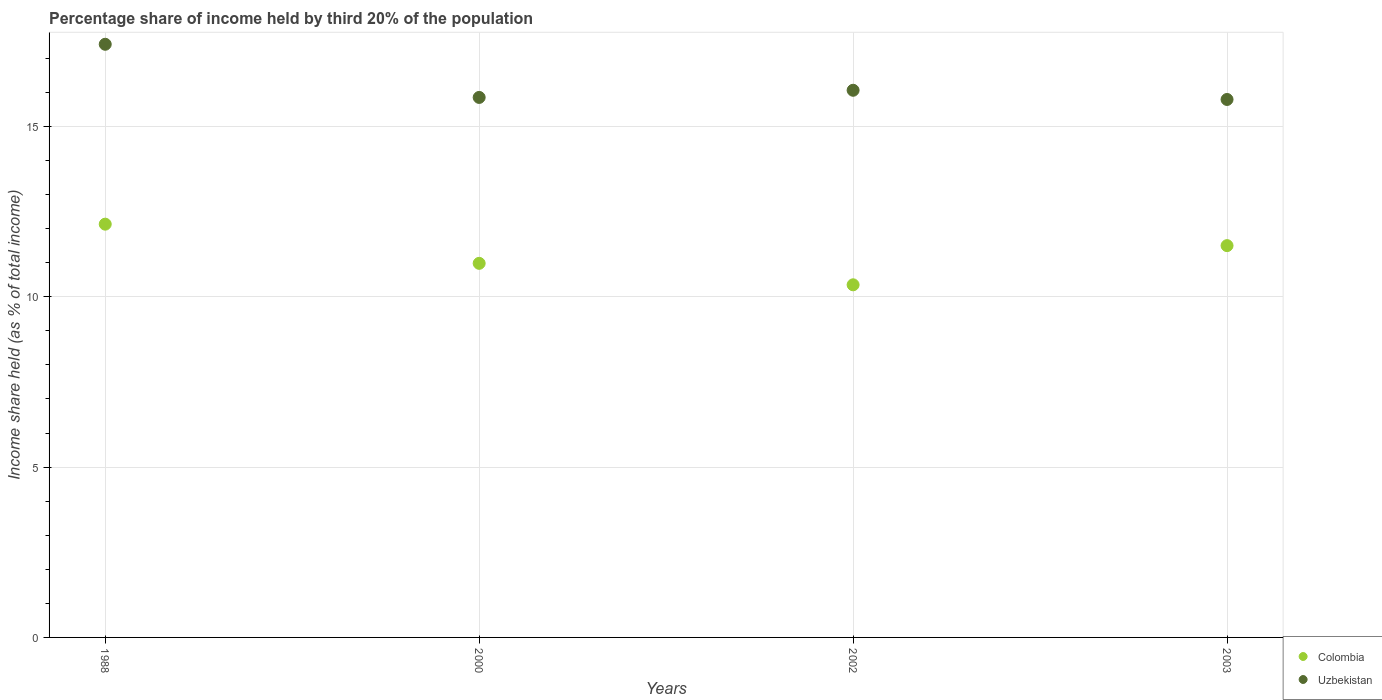How many different coloured dotlines are there?
Provide a short and direct response. 2. Is the number of dotlines equal to the number of legend labels?
Give a very brief answer. Yes. What is the share of income held by third 20% of the population in Colombia in 2000?
Provide a short and direct response. 10.98. Across all years, what is the maximum share of income held by third 20% of the population in Uzbekistan?
Provide a short and direct response. 17.41. Across all years, what is the minimum share of income held by third 20% of the population in Uzbekistan?
Give a very brief answer. 15.79. What is the total share of income held by third 20% of the population in Uzbekistan in the graph?
Provide a short and direct response. 65.11. What is the difference between the share of income held by third 20% of the population in Uzbekistan in 1988 and that in 2000?
Give a very brief answer. 1.56. What is the difference between the share of income held by third 20% of the population in Colombia in 1988 and the share of income held by third 20% of the population in Uzbekistan in 2003?
Provide a short and direct response. -3.66. What is the average share of income held by third 20% of the population in Uzbekistan per year?
Provide a succinct answer. 16.28. In the year 2002, what is the difference between the share of income held by third 20% of the population in Uzbekistan and share of income held by third 20% of the population in Colombia?
Ensure brevity in your answer.  5.71. In how many years, is the share of income held by third 20% of the population in Uzbekistan greater than 16 %?
Make the answer very short. 2. What is the ratio of the share of income held by third 20% of the population in Uzbekistan in 2000 to that in 2003?
Provide a succinct answer. 1. Is the share of income held by third 20% of the population in Uzbekistan in 2000 less than that in 2003?
Make the answer very short. No. Is the difference between the share of income held by third 20% of the population in Uzbekistan in 1988 and 2003 greater than the difference between the share of income held by third 20% of the population in Colombia in 1988 and 2003?
Ensure brevity in your answer.  Yes. What is the difference between the highest and the second highest share of income held by third 20% of the population in Uzbekistan?
Provide a succinct answer. 1.35. What is the difference between the highest and the lowest share of income held by third 20% of the population in Colombia?
Your answer should be very brief. 1.78. In how many years, is the share of income held by third 20% of the population in Uzbekistan greater than the average share of income held by third 20% of the population in Uzbekistan taken over all years?
Your answer should be very brief. 1. Is the sum of the share of income held by third 20% of the population in Colombia in 2000 and 2003 greater than the maximum share of income held by third 20% of the population in Uzbekistan across all years?
Your answer should be compact. Yes. Is the share of income held by third 20% of the population in Colombia strictly greater than the share of income held by third 20% of the population in Uzbekistan over the years?
Provide a short and direct response. No. Is the share of income held by third 20% of the population in Colombia strictly less than the share of income held by third 20% of the population in Uzbekistan over the years?
Keep it short and to the point. Yes. What is the difference between two consecutive major ticks on the Y-axis?
Your answer should be compact. 5. Does the graph contain any zero values?
Keep it short and to the point. No. Does the graph contain grids?
Your answer should be very brief. Yes. Where does the legend appear in the graph?
Provide a short and direct response. Bottom right. How many legend labels are there?
Keep it short and to the point. 2. How are the legend labels stacked?
Provide a short and direct response. Vertical. What is the title of the graph?
Provide a succinct answer. Percentage share of income held by third 20% of the population. What is the label or title of the X-axis?
Ensure brevity in your answer.  Years. What is the label or title of the Y-axis?
Keep it short and to the point. Income share held (as % of total income). What is the Income share held (as % of total income) in Colombia in 1988?
Provide a succinct answer. 12.13. What is the Income share held (as % of total income) in Uzbekistan in 1988?
Keep it short and to the point. 17.41. What is the Income share held (as % of total income) in Colombia in 2000?
Your response must be concise. 10.98. What is the Income share held (as % of total income) in Uzbekistan in 2000?
Ensure brevity in your answer.  15.85. What is the Income share held (as % of total income) in Colombia in 2002?
Your answer should be very brief. 10.35. What is the Income share held (as % of total income) in Uzbekistan in 2002?
Provide a short and direct response. 16.06. What is the Income share held (as % of total income) in Colombia in 2003?
Offer a very short reply. 11.5. What is the Income share held (as % of total income) of Uzbekistan in 2003?
Provide a short and direct response. 15.79. Across all years, what is the maximum Income share held (as % of total income) in Colombia?
Your answer should be compact. 12.13. Across all years, what is the maximum Income share held (as % of total income) of Uzbekistan?
Your answer should be compact. 17.41. Across all years, what is the minimum Income share held (as % of total income) in Colombia?
Your answer should be very brief. 10.35. Across all years, what is the minimum Income share held (as % of total income) in Uzbekistan?
Offer a terse response. 15.79. What is the total Income share held (as % of total income) of Colombia in the graph?
Give a very brief answer. 44.96. What is the total Income share held (as % of total income) of Uzbekistan in the graph?
Your response must be concise. 65.11. What is the difference between the Income share held (as % of total income) of Colombia in 1988 and that in 2000?
Offer a very short reply. 1.15. What is the difference between the Income share held (as % of total income) of Uzbekistan in 1988 and that in 2000?
Your answer should be very brief. 1.56. What is the difference between the Income share held (as % of total income) of Colombia in 1988 and that in 2002?
Provide a short and direct response. 1.78. What is the difference between the Income share held (as % of total income) in Uzbekistan in 1988 and that in 2002?
Your response must be concise. 1.35. What is the difference between the Income share held (as % of total income) in Colombia in 1988 and that in 2003?
Keep it short and to the point. 0.63. What is the difference between the Income share held (as % of total income) of Uzbekistan in 1988 and that in 2003?
Your answer should be compact. 1.62. What is the difference between the Income share held (as % of total income) in Colombia in 2000 and that in 2002?
Make the answer very short. 0.63. What is the difference between the Income share held (as % of total income) of Uzbekistan in 2000 and that in 2002?
Give a very brief answer. -0.21. What is the difference between the Income share held (as % of total income) of Colombia in 2000 and that in 2003?
Provide a succinct answer. -0.52. What is the difference between the Income share held (as % of total income) of Uzbekistan in 2000 and that in 2003?
Your response must be concise. 0.06. What is the difference between the Income share held (as % of total income) in Colombia in 2002 and that in 2003?
Keep it short and to the point. -1.15. What is the difference between the Income share held (as % of total income) in Uzbekistan in 2002 and that in 2003?
Your answer should be very brief. 0.27. What is the difference between the Income share held (as % of total income) of Colombia in 1988 and the Income share held (as % of total income) of Uzbekistan in 2000?
Your answer should be very brief. -3.72. What is the difference between the Income share held (as % of total income) in Colombia in 1988 and the Income share held (as % of total income) in Uzbekistan in 2002?
Offer a terse response. -3.93. What is the difference between the Income share held (as % of total income) of Colombia in 1988 and the Income share held (as % of total income) of Uzbekistan in 2003?
Offer a terse response. -3.66. What is the difference between the Income share held (as % of total income) in Colombia in 2000 and the Income share held (as % of total income) in Uzbekistan in 2002?
Provide a succinct answer. -5.08. What is the difference between the Income share held (as % of total income) of Colombia in 2000 and the Income share held (as % of total income) of Uzbekistan in 2003?
Make the answer very short. -4.81. What is the difference between the Income share held (as % of total income) of Colombia in 2002 and the Income share held (as % of total income) of Uzbekistan in 2003?
Provide a short and direct response. -5.44. What is the average Income share held (as % of total income) in Colombia per year?
Keep it short and to the point. 11.24. What is the average Income share held (as % of total income) in Uzbekistan per year?
Keep it short and to the point. 16.28. In the year 1988, what is the difference between the Income share held (as % of total income) of Colombia and Income share held (as % of total income) of Uzbekistan?
Give a very brief answer. -5.28. In the year 2000, what is the difference between the Income share held (as % of total income) of Colombia and Income share held (as % of total income) of Uzbekistan?
Your response must be concise. -4.87. In the year 2002, what is the difference between the Income share held (as % of total income) in Colombia and Income share held (as % of total income) in Uzbekistan?
Provide a succinct answer. -5.71. In the year 2003, what is the difference between the Income share held (as % of total income) in Colombia and Income share held (as % of total income) in Uzbekistan?
Provide a succinct answer. -4.29. What is the ratio of the Income share held (as % of total income) in Colombia in 1988 to that in 2000?
Your response must be concise. 1.1. What is the ratio of the Income share held (as % of total income) of Uzbekistan in 1988 to that in 2000?
Your answer should be compact. 1.1. What is the ratio of the Income share held (as % of total income) of Colombia in 1988 to that in 2002?
Offer a very short reply. 1.17. What is the ratio of the Income share held (as % of total income) of Uzbekistan in 1988 to that in 2002?
Make the answer very short. 1.08. What is the ratio of the Income share held (as % of total income) in Colombia in 1988 to that in 2003?
Provide a short and direct response. 1.05. What is the ratio of the Income share held (as % of total income) in Uzbekistan in 1988 to that in 2003?
Provide a short and direct response. 1.1. What is the ratio of the Income share held (as % of total income) of Colombia in 2000 to that in 2002?
Provide a succinct answer. 1.06. What is the ratio of the Income share held (as % of total income) in Uzbekistan in 2000 to that in 2002?
Provide a short and direct response. 0.99. What is the ratio of the Income share held (as % of total income) of Colombia in 2000 to that in 2003?
Provide a short and direct response. 0.95. What is the ratio of the Income share held (as % of total income) of Colombia in 2002 to that in 2003?
Your response must be concise. 0.9. What is the ratio of the Income share held (as % of total income) in Uzbekistan in 2002 to that in 2003?
Make the answer very short. 1.02. What is the difference between the highest and the second highest Income share held (as % of total income) of Colombia?
Your answer should be very brief. 0.63. What is the difference between the highest and the second highest Income share held (as % of total income) in Uzbekistan?
Provide a short and direct response. 1.35. What is the difference between the highest and the lowest Income share held (as % of total income) in Colombia?
Your answer should be compact. 1.78. What is the difference between the highest and the lowest Income share held (as % of total income) in Uzbekistan?
Provide a short and direct response. 1.62. 